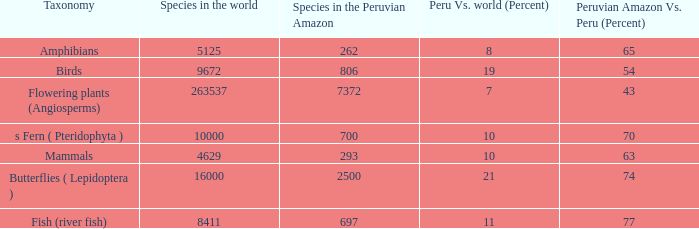What's the minimum species in the peruvian amazon with taxonomy s fern ( pteridophyta ) 700.0. 